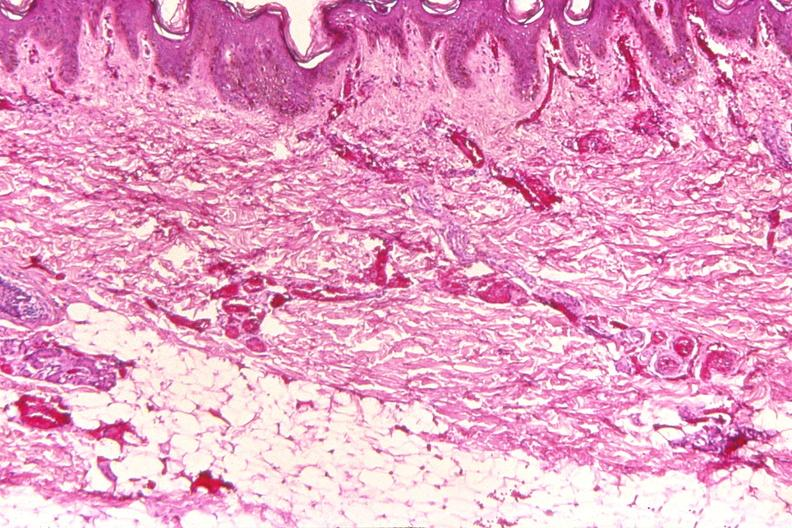what does this image show?
Answer the question using a single word or phrase. Skin 